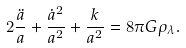Convert formula to latex. <formula><loc_0><loc_0><loc_500><loc_500>2 \frac { \ddot { a } } { a } + \frac { \dot { a } ^ { 2 } } { a ^ { 2 } } + \frac { k } { a ^ { 2 } } = 8 \pi G \rho _ { \lambda } .</formula> 